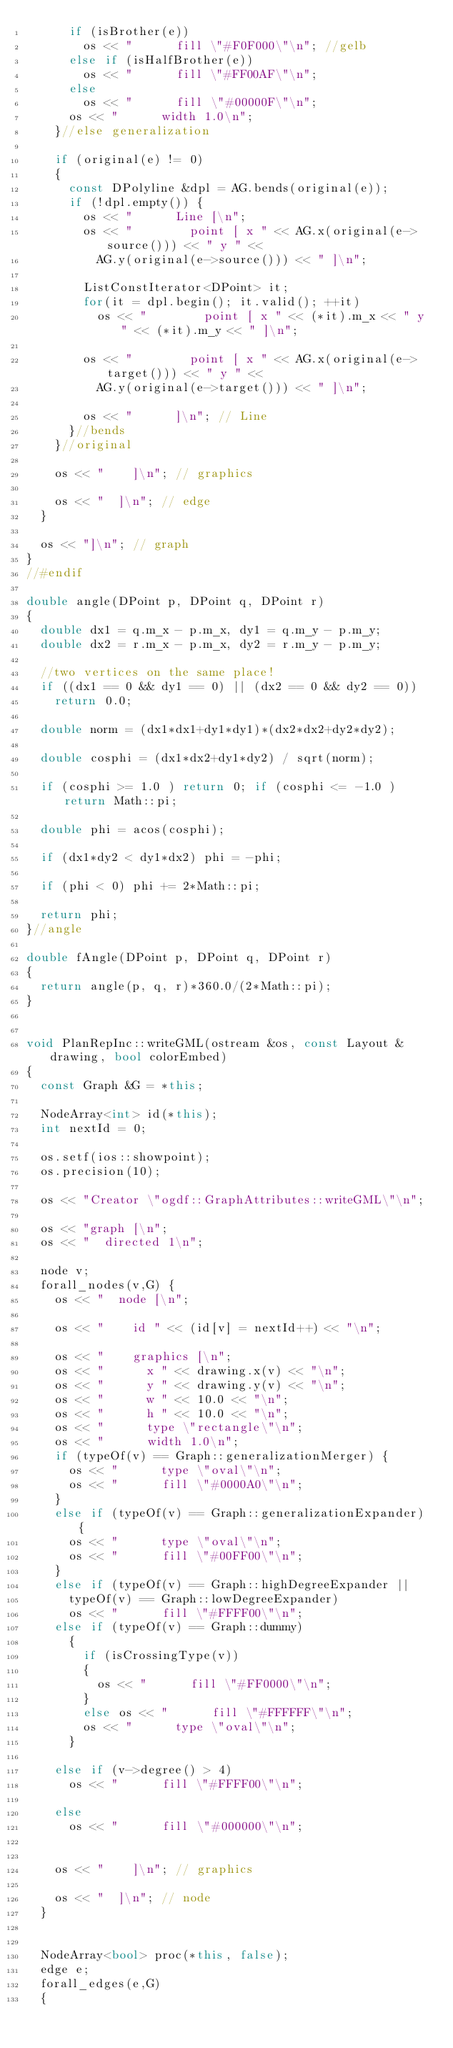<code> <loc_0><loc_0><loc_500><loc_500><_C++_>			if (isBrother(e))
				os << "      fill \"#F0F000\"\n"; //gelb
			else if (isHalfBrother(e))
				os << "      fill \"#FF00AF\"\n";
			else
				os << "      fill \"#00000F\"\n";
			os << "      width 1.0\n";
		}//else generalization

		if (original(e) != 0)
		{
			const DPolyline &dpl = AG.bends(original(e));
			if (!dpl.empty()) {
				os << "      Line [\n";
				os << "        point [ x " << AG.x(original(e->source())) << " y " <<
					AG.y(original(e->source())) << " ]\n";

				ListConstIterator<DPoint> it;
				for(it = dpl.begin(); it.valid(); ++it)
					os << "        point [ x " << (*it).m_x << " y " << (*it).m_y << " ]\n";

				os << "        point [ x " << AG.x(original(e->target())) << " y " <<
					AG.y(original(e->target())) << " ]\n";

				os << "      ]\n"; // Line
			}//bends
		}//original

		os << "    ]\n"; // graphics

		os << "  ]\n"; // edge
	}

	os << "]\n"; // graph
}
//#endif

double angle(DPoint p, DPoint q, DPoint r)
{
	double dx1 = q.m_x - p.m_x, dy1 = q.m_y - p.m_y;
	double dx2 = r.m_x - p.m_x, dy2 = r.m_y - p.m_y;

	//two vertices on the same place!
	if ((dx1 == 0 && dy1 == 0) || (dx2 == 0 && dy2 == 0))
		return 0.0;

	double norm = (dx1*dx1+dy1*dy1)*(dx2*dx2+dy2*dy2);

	double cosphi = (dx1*dx2+dy1*dy2) / sqrt(norm);

	if (cosphi >= 1.0 ) return 0; if (cosphi <= -1.0 ) return Math::pi;

	double phi = acos(cosphi);

	if (dx1*dy2 < dy1*dx2) phi = -phi;

	if (phi < 0) phi += 2*Math::pi;

	return phi;
}//angle

double fAngle(DPoint p, DPoint q, DPoint r)
{
	return angle(p, q, r)*360.0/(2*Math::pi);
}


void PlanRepInc::writeGML(ostream &os, const Layout &drawing, bool colorEmbed)
{
	const Graph &G = *this;

	NodeArray<int> id(*this);
	int nextId = 0;

	os.setf(ios::showpoint);
	os.precision(10);

	os << "Creator \"ogdf::GraphAttributes::writeGML\"\n";

	os << "graph [\n";
	os << "  directed 1\n";

	node v;
	forall_nodes(v,G) {
		os << "  node [\n";

		os << "    id " << (id[v] = nextId++) << "\n";

		os << "    graphics [\n";
		os << "      x " << drawing.x(v) << "\n";
		os << "      y " << drawing.y(v) << "\n";
		os << "      w " << 10.0 << "\n";
		os << "      h " << 10.0 << "\n";
		os << "      type \"rectangle\"\n";
		os << "      width 1.0\n";
		if (typeOf(v) == Graph::generalizationMerger) {
			os << "      type \"oval\"\n";
			os << "      fill \"#0000A0\"\n";
		}
		else if (typeOf(v) == Graph::generalizationExpander) {
			os << "      type \"oval\"\n";
			os << "      fill \"#00FF00\"\n";
		}
		else if (typeOf(v) == Graph::highDegreeExpander ||
			typeOf(v) == Graph::lowDegreeExpander)
			os << "      fill \"#FFFF00\"\n";
		else if (typeOf(v) == Graph::dummy)
			{
				if (isCrossingType(v))
				{
					os << "      fill \"#FF0000\"\n";
				}
				else os << "      fill \"#FFFFFF\"\n";
				os << "      type \"oval\"\n";
			}

		else if (v->degree() > 4)
			os << "      fill \"#FFFF00\"\n";

		else
			os << "      fill \"#000000\"\n";


		os << "    ]\n"; // graphics

		os << "  ]\n"; // node
	}


	NodeArray<bool> proc(*this, false);
	edge e;
	forall_edges(e,G)
	{</code> 